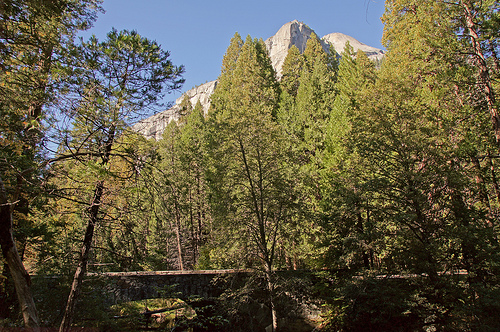<image>
Can you confirm if the leaves is on the tree? Yes. Looking at the image, I can see the leaves is positioned on top of the tree, with the tree providing support. 